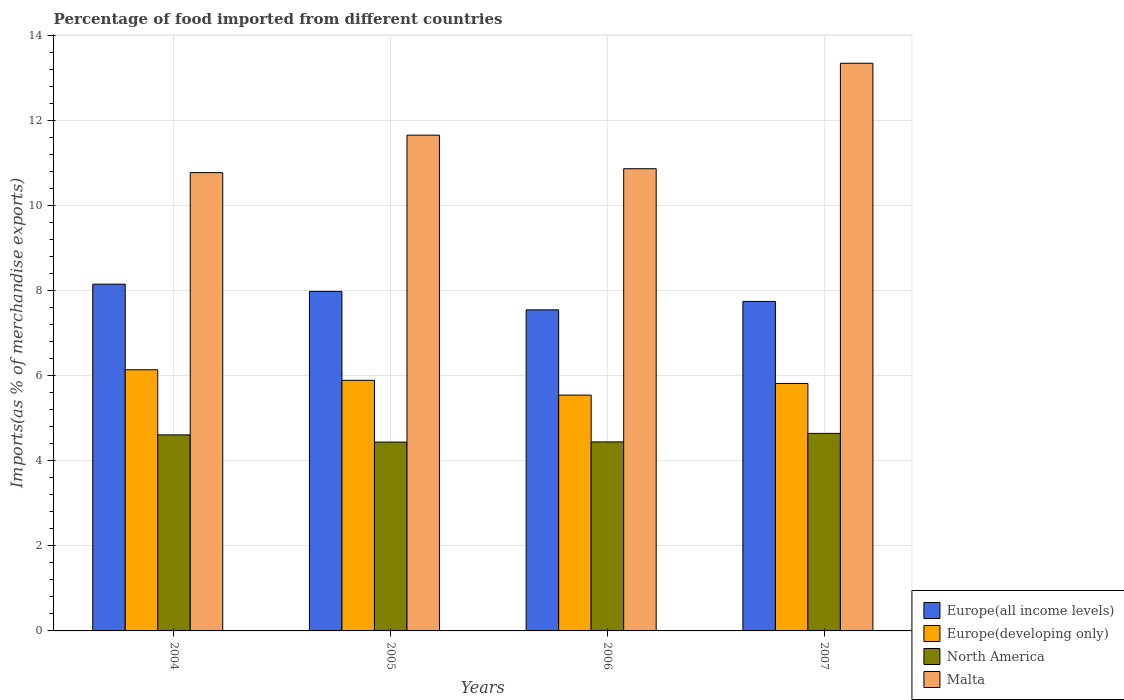How many different coloured bars are there?
Provide a succinct answer. 4. Are the number of bars per tick equal to the number of legend labels?
Offer a terse response. Yes. How many bars are there on the 4th tick from the left?
Give a very brief answer. 4. What is the label of the 3rd group of bars from the left?
Keep it short and to the point. 2006. In how many cases, is the number of bars for a given year not equal to the number of legend labels?
Offer a very short reply. 0. What is the percentage of imports to different countries in Europe(developing only) in 2006?
Make the answer very short. 5.54. Across all years, what is the maximum percentage of imports to different countries in Europe(developing only)?
Ensure brevity in your answer.  6.14. Across all years, what is the minimum percentage of imports to different countries in Europe(all income levels)?
Your answer should be very brief. 7.54. In which year was the percentage of imports to different countries in Europe(all income levels) minimum?
Your response must be concise. 2006. What is the total percentage of imports to different countries in North America in the graph?
Offer a very short reply. 18.13. What is the difference between the percentage of imports to different countries in Europe(all income levels) in 2004 and that in 2007?
Ensure brevity in your answer.  0.41. What is the difference between the percentage of imports to different countries in North America in 2005 and the percentage of imports to different countries in Europe(all income levels) in 2004?
Ensure brevity in your answer.  -3.71. What is the average percentage of imports to different countries in Europe(all income levels) per year?
Your answer should be very brief. 7.85. In the year 2005, what is the difference between the percentage of imports to different countries in Malta and percentage of imports to different countries in North America?
Your response must be concise. 7.21. In how many years, is the percentage of imports to different countries in Europe(all income levels) greater than 3.2 %?
Provide a short and direct response. 4. What is the ratio of the percentage of imports to different countries in Europe(all income levels) in 2004 to that in 2007?
Ensure brevity in your answer.  1.05. Is the difference between the percentage of imports to different countries in Malta in 2004 and 2007 greater than the difference between the percentage of imports to different countries in North America in 2004 and 2007?
Your response must be concise. No. What is the difference between the highest and the second highest percentage of imports to different countries in North America?
Offer a very short reply. 0.04. What is the difference between the highest and the lowest percentage of imports to different countries in Malta?
Provide a short and direct response. 2.57. What does the 3rd bar from the left in 2007 represents?
Give a very brief answer. North America. Are all the bars in the graph horizontal?
Provide a short and direct response. No. How many years are there in the graph?
Offer a very short reply. 4. What is the difference between two consecutive major ticks on the Y-axis?
Your answer should be very brief. 2. Are the values on the major ticks of Y-axis written in scientific E-notation?
Make the answer very short. No. Does the graph contain any zero values?
Offer a very short reply. No. Does the graph contain grids?
Provide a short and direct response. Yes. How many legend labels are there?
Your answer should be very brief. 4. How are the legend labels stacked?
Give a very brief answer. Vertical. What is the title of the graph?
Offer a terse response. Percentage of food imported from different countries. What is the label or title of the X-axis?
Give a very brief answer. Years. What is the label or title of the Y-axis?
Keep it short and to the point. Imports(as % of merchandise exports). What is the Imports(as % of merchandise exports) in Europe(all income levels) in 2004?
Offer a terse response. 8.15. What is the Imports(as % of merchandise exports) of Europe(developing only) in 2004?
Offer a very short reply. 6.14. What is the Imports(as % of merchandise exports) in North America in 2004?
Make the answer very short. 4.61. What is the Imports(as % of merchandise exports) of Malta in 2004?
Offer a very short reply. 10.77. What is the Imports(as % of merchandise exports) in Europe(all income levels) in 2005?
Your answer should be compact. 7.98. What is the Imports(as % of merchandise exports) of Europe(developing only) in 2005?
Give a very brief answer. 5.89. What is the Imports(as % of merchandise exports) in North America in 2005?
Your response must be concise. 4.44. What is the Imports(as % of merchandise exports) in Malta in 2005?
Ensure brevity in your answer.  11.65. What is the Imports(as % of merchandise exports) in Europe(all income levels) in 2006?
Your answer should be very brief. 7.54. What is the Imports(as % of merchandise exports) of Europe(developing only) in 2006?
Give a very brief answer. 5.54. What is the Imports(as % of merchandise exports) in North America in 2006?
Provide a succinct answer. 4.44. What is the Imports(as % of merchandise exports) in Malta in 2006?
Keep it short and to the point. 10.86. What is the Imports(as % of merchandise exports) of Europe(all income levels) in 2007?
Your response must be concise. 7.74. What is the Imports(as % of merchandise exports) of Europe(developing only) in 2007?
Provide a short and direct response. 5.82. What is the Imports(as % of merchandise exports) in North America in 2007?
Keep it short and to the point. 4.64. What is the Imports(as % of merchandise exports) of Malta in 2007?
Make the answer very short. 13.34. Across all years, what is the maximum Imports(as % of merchandise exports) in Europe(all income levels)?
Ensure brevity in your answer.  8.15. Across all years, what is the maximum Imports(as % of merchandise exports) in Europe(developing only)?
Give a very brief answer. 6.14. Across all years, what is the maximum Imports(as % of merchandise exports) in North America?
Offer a terse response. 4.64. Across all years, what is the maximum Imports(as % of merchandise exports) in Malta?
Your response must be concise. 13.34. Across all years, what is the minimum Imports(as % of merchandise exports) of Europe(all income levels)?
Offer a very short reply. 7.54. Across all years, what is the minimum Imports(as % of merchandise exports) of Europe(developing only)?
Provide a short and direct response. 5.54. Across all years, what is the minimum Imports(as % of merchandise exports) of North America?
Keep it short and to the point. 4.44. Across all years, what is the minimum Imports(as % of merchandise exports) of Malta?
Your answer should be very brief. 10.77. What is the total Imports(as % of merchandise exports) of Europe(all income levels) in the graph?
Your answer should be very brief. 31.41. What is the total Imports(as % of merchandise exports) of Europe(developing only) in the graph?
Your answer should be compact. 23.38. What is the total Imports(as % of merchandise exports) of North America in the graph?
Provide a short and direct response. 18.13. What is the total Imports(as % of merchandise exports) in Malta in the graph?
Provide a short and direct response. 46.62. What is the difference between the Imports(as % of merchandise exports) in Europe(all income levels) in 2004 and that in 2005?
Provide a short and direct response. 0.17. What is the difference between the Imports(as % of merchandise exports) in Europe(developing only) in 2004 and that in 2005?
Offer a very short reply. 0.25. What is the difference between the Imports(as % of merchandise exports) in North America in 2004 and that in 2005?
Ensure brevity in your answer.  0.17. What is the difference between the Imports(as % of merchandise exports) in Malta in 2004 and that in 2005?
Provide a succinct answer. -0.88. What is the difference between the Imports(as % of merchandise exports) in Europe(all income levels) in 2004 and that in 2006?
Give a very brief answer. 0.6. What is the difference between the Imports(as % of merchandise exports) of Europe(developing only) in 2004 and that in 2006?
Provide a short and direct response. 0.6. What is the difference between the Imports(as % of merchandise exports) of North America in 2004 and that in 2006?
Your answer should be very brief. 0.16. What is the difference between the Imports(as % of merchandise exports) in Malta in 2004 and that in 2006?
Offer a terse response. -0.09. What is the difference between the Imports(as % of merchandise exports) in Europe(all income levels) in 2004 and that in 2007?
Give a very brief answer. 0.41. What is the difference between the Imports(as % of merchandise exports) in Europe(developing only) in 2004 and that in 2007?
Offer a very short reply. 0.32. What is the difference between the Imports(as % of merchandise exports) in North America in 2004 and that in 2007?
Your answer should be compact. -0.04. What is the difference between the Imports(as % of merchandise exports) of Malta in 2004 and that in 2007?
Your response must be concise. -2.57. What is the difference between the Imports(as % of merchandise exports) in Europe(all income levels) in 2005 and that in 2006?
Your answer should be compact. 0.43. What is the difference between the Imports(as % of merchandise exports) of Europe(developing only) in 2005 and that in 2006?
Offer a very short reply. 0.35. What is the difference between the Imports(as % of merchandise exports) of North America in 2005 and that in 2006?
Make the answer very short. -0. What is the difference between the Imports(as % of merchandise exports) in Malta in 2005 and that in 2006?
Ensure brevity in your answer.  0.79. What is the difference between the Imports(as % of merchandise exports) in Europe(all income levels) in 2005 and that in 2007?
Give a very brief answer. 0.24. What is the difference between the Imports(as % of merchandise exports) in Europe(developing only) in 2005 and that in 2007?
Offer a terse response. 0.07. What is the difference between the Imports(as % of merchandise exports) in North America in 2005 and that in 2007?
Offer a terse response. -0.2. What is the difference between the Imports(as % of merchandise exports) in Malta in 2005 and that in 2007?
Offer a terse response. -1.69. What is the difference between the Imports(as % of merchandise exports) of Europe(all income levels) in 2006 and that in 2007?
Your answer should be very brief. -0.2. What is the difference between the Imports(as % of merchandise exports) of Europe(developing only) in 2006 and that in 2007?
Offer a terse response. -0.27. What is the difference between the Imports(as % of merchandise exports) of North America in 2006 and that in 2007?
Ensure brevity in your answer.  -0.2. What is the difference between the Imports(as % of merchandise exports) in Malta in 2006 and that in 2007?
Make the answer very short. -2.48. What is the difference between the Imports(as % of merchandise exports) of Europe(all income levels) in 2004 and the Imports(as % of merchandise exports) of Europe(developing only) in 2005?
Your response must be concise. 2.26. What is the difference between the Imports(as % of merchandise exports) in Europe(all income levels) in 2004 and the Imports(as % of merchandise exports) in North America in 2005?
Your answer should be very brief. 3.71. What is the difference between the Imports(as % of merchandise exports) in Europe(all income levels) in 2004 and the Imports(as % of merchandise exports) in Malta in 2005?
Ensure brevity in your answer.  -3.5. What is the difference between the Imports(as % of merchandise exports) in Europe(developing only) in 2004 and the Imports(as % of merchandise exports) in North America in 2005?
Offer a terse response. 1.7. What is the difference between the Imports(as % of merchandise exports) of Europe(developing only) in 2004 and the Imports(as % of merchandise exports) of Malta in 2005?
Make the answer very short. -5.51. What is the difference between the Imports(as % of merchandise exports) in North America in 2004 and the Imports(as % of merchandise exports) in Malta in 2005?
Provide a succinct answer. -7.04. What is the difference between the Imports(as % of merchandise exports) of Europe(all income levels) in 2004 and the Imports(as % of merchandise exports) of Europe(developing only) in 2006?
Your answer should be very brief. 2.61. What is the difference between the Imports(as % of merchandise exports) in Europe(all income levels) in 2004 and the Imports(as % of merchandise exports) in North America in 2006?
Your response must be concise. 3.71. What is the difference between the Imports(as % of merchandise exports) of Europe(all income levels) in 2004 and the Imports(as % of merchandise exports) of Malta in 2006?
Offer a very short reply. -2.71. What is the difference between the Imports(as % of merchandise exports) in Europe(developing only) in 2004 and the Imports(as % of merchandise exports) in North America in 2006?
Keep it short and to the point. 1.69. What is the difference between the Imports(as % of merchandise exports) in Europe(developing only) in 2004 and the Imports(as % of merchandise exports) in Malta in 2006?
Offer a terse response. -4.72. What is the difference between the Imports(as % of merchandise exports) of North America in 2004 and the Imports(as % of merchandise exports) of Malta in 2006?
Offer a very short reply. -6.25. What is the difference between the Imports(as % of merchandise exports) in Europe(all income levels) in 2004 and the Imports(as % of merchandise exports) in Europe(developing only) in 2007?
Offer a terse response. 2.33. What is the difference between the Imports(as % of merchandise exports) of Europe(all income levels) in 2004 and the Imports(as % of merchandise exports) of North America in 2007?
Offer a terse response. 3.51. What is the difference between the Imports(as % of merchandise exports) in Europe(all income levels) in 2004 and the Imports(as % of merchandise exports) in Malta in 2007?
Offer a very short reply. -5.19. What is the difference between the Imports(as % of merchandise exports) of Europe(developing only) in 2004 and the Imports(as % of merchandise exports) of North America in 2007?
Your answer should be compact. 1.49. What is the difference between the Imports(as % of merchandise exports) of Europe(developing only) in 2004 and the Imports(as % of merchandise exports) of Malta in 2007?
Your answer should be very brief. -7.2. What is the difference between the Imports(as % of merchandise exports) of North America in 2004 and the Imports(as % of merchandise exports) of Malta in 2007?
Keep it short and to the point. -8.73. What is the difference between the Imports(as % of merchandise exports) in Europe(all income levels) in 2005 and the Imports(as % of merchandise exports) in Europe(developing only) in 2006?
Offer a terse response. 2.44. What is the difference between the Imports(as % of merchandise exports) in Europe(all income levels) in 2005 and the Imports(as % of merchandise exports) in North America in 2006?
Your response must be concise. 3.54. What is the difference between the Imports(as % of merchandise exports) of Europe(all income levels) in 2005 and the Imports(as % of merchandise exports) of Malta in 2006?
Keep it short and to the point. -2.88. What is the difference between the Imports(as % of merchandise exports) in Europe(developing only) in 2005 and the Imports(as % of merchandise exports) in North America in 2006?
Make the answer very short. 1.45. What is the difference between the Imports(as % of merchandise exports) of Europe(developing only) in 2005 and the Imports(as % of merchandise exports) of Malta in 2006?
Your answer should be very brief. -4.97. What is the difference between the Imports(as % of merchandise exports) in North America in 2005 and the Imports(as % of merchandise exports) in Malta in 2006?
Offer a terse response. -6.42. What is the difference between the Imports(as % of merchandise exports) of Europe(all income levels) in 2005 and the Imports(as % of merchandise exports) of Europe(developing only) in 2007?
Provide a succinct answer. 2.16. What is the difference between the Imports(as % of merchandise exports) of Europe(all income levels) in 2005 and the Imports(as % of merchandise exports) of North America in 2007?
Offer a very short reply. 3.34. What is the difference between the Imports(as % of merchandise exports) of Europe(all income levels) in 2005 and the Imports(as % of merchandise exports) of Malta in 2007?
Provide a succinct answer. -5.36. What is the difference between the Imports(as % of merchandise exports) in Europe(developing only) in 2005 and the Imports(as % of merchandise exports) in North America in 2007?
Give a very brief answer. 1.25. What is the difference between the Imports(as % of merchandise exports) of Europe(developing only) in 2005 and the Imports(as % of merchandise exports) of Malta in 2007?
Keep it short and to the point. -7.45. What is the difference between the Imports(as % of merchandise exports) of North America in 2005 and the Imports(as % of merchandise exports) of Malta in 2007?
Give a very brief answer. -8.9. What is the difference between the Imports(as % of merchandise exports) of Europe(all income levels) in 2006 and the Imports(as % of merchandise exports) of Europe(developing only) in 2007?
Your response must be concise. 1.73. What is the difference between the Imports(as % of merchandise exports) of Europe(all income levels) in 2006 and the Imports(as % of merchandise exports) of North America in 2007?
Your answer should be compact. 2.9. What is the difference between the Imports(as % of merchandise exports) of Europe(all income levels) in 2006 and the Imports(as % of merchandise exports) of Malta in 2007?
Offer a terse response. -5.79. What is the difference between the Imports(as % of merchandise exports) in Europe(developing only) in 2006 and the Imports(as % of merchandise exports) in North America in 2007?
Your answer should be compact. 0.9. What is the difference between the Imports(as % of merchandise exports) in Europe(developing only) in 2006 and the Imports(as % of merchandise exports) in Malta in 2007?
Offer a terse response. -7.8. What is the difference between the Imports(as % of merchandise exports) of North America in 2006 and the Imports(as % of merchandise exports) of Malta in 2007?
Offer a very short reply. -8.9. What is the average Imports(as % of merchandise exports) of Europe(all income levels) per year?
Provide a succinct answer. 7.85. What is the average Imports(as % of merchandise exports) in Europe(developing only) per year?
Your answer should be very brief. 5.85. What is the average Imports(as % of merchandise exports) of North America per year?
Keep it short and to the point. 4.53. What is the average Imports(as % of merchandise exports) of Malta per year?
Offer a terse response. 11.65. In the year 2004, what is the difference between the Imports(as % of merchandise exports) of Europe(all income levels) and Imports(as % of merchandise exports) of Europe(developing only)?
Make the answer very short. 2.01. In the year 2004, what is the difference between the Imports(as % of merchandise exports) of Europe(all income levels) and Imports(as % of merchandise exports) of North America?
Offer a very short reply. 3.54. In the year 2004, what is the difference between the Imports(as % of merchandise exports) in Europe(all income levels) and Imports(as % of merchandise exports) in Malta?
Provide a short and direct response. -2.62. In the year 2004, what is the difference between the Imports(as % of merchandise exports) of Europe(developing only) and Imports(as % of merchandise exports) of North America?
Your response must be concise. 1.53. In the year 2004, what is the difference between the Imports(as % of merchandise exports) in Europe(developing only) and Imports(as % of merchandise exports) in Malta?
Provide a succinct answer. -4.63. In the year 2004, what is the difference between the Imports(as % of merchandise exports) of North America and Imports(as % of merchandise exports) of Malta?
Provide a succinct answer. -6.16. In the year 2005, what is the difference between the Imports(as % of merchandise exports) of Europe(all income levels) and Imports(as % of merchandise exports) of Europe(developing only)?
Your response must be concise. 2.09. In the year 2005, what is the difference between the Imports(as % of merchandise exports) in Europe(all income levels) and Imports(as % of merchandise exports) in North America?
Provide a succinct answer. 3.54. In the year 2005, what is the difference between the Imports(as % of merchandise exports) in Europe(all income levels) and Imports(as % of merchandise exports) in Malta?
Keep it short and to the point. -3.67. In the year 2005, what is the difference between the Imports(as % of merchandise exports) in Europe(developing only) and Imports(as % of merchandise exports) in North America?
Give a very brief answer. 1.45. In the year 2005, what is the difference between the Imports(as % of merchandise exports) in Europe(developing only) and Imports(as % of merchandise exports) in Malta?
Give a very brief answer. -5.76. In the year 2005, what is the difference between the Imports(as % of merchandise exports) in North America and Imports(as % of merchandise exports) in Malta?
Keep it short and to the point. -7.21. In the year 2006, what is the difference between the Imports(as % of merchandise exports) in Europe(all income levels) and Imports(as % of merchandise exports) in Europe(developing only)?
Offer a very short reply. 2. In the year 2006, what is the difference between the Imports(as % of merchandise exports) of Europe(all income levels) and Imports(as % of merchandise exports) of North America?
Provide a succinct answer. 3.1. In the year 2006, what is the difference between the Imports(as % of merchandise exports) in Europe(all income levels) and Imports(as % of merchandise exports) in Malta?
Keep it short and to the point. -3.32. In the year 2006, what is the difference between the Imports(as % of merchandise exports) in Europe(developing only) and Imports(as % of merchandise exports) in North America?
Offer a terse response. 1.1. In the year 2006, what is the difference between the Imports(as % of merchandise exports) in Europe(developing only) and Imports(as % of merchandise exports) in Malta?
Your answer should be compact. -5.32. In the year 2006, what is the difference between the Imports(as % of merchandise exports) in North America and Imports(as % of merchandise exports) in Malta?
Your response must be concise. -6.42. In the year 2007, what is the difference between the Imports(as % of merchandise exports) in Europe(all income levels) and Imports(as % of merchandise exports) in Europe(developing only)?
Give a very brief answer. 1.93. In the year 2007, what is the difference between the Imports(as % of merchandise exports) in Europe(all income levels) and Imports(as % of merchandise exports) in North America?
Offer a very short reply. 3.1. In the year 2007, what is the difference between the Imports(as % of merchandise exports) of Europe(all income levels) and Imports(as % of merchandise exports) of Malta?
Give a very brief answer. -5.6. In the year 2007, what is the difference between the Imports(as % of merchandise exports) of Europe(developing only) and Imports(as % of merchandise exports) of North America?
Keep it short and to the point. 1.17. In the year 2007, what is the difference between the Imports(as % of merchandise exports) in Europe(developing only) and Imports(as % of merchandise exports) in Malta?
Provide a succinct answer. -7.52. In the year 2007, what is the difference between the Imports(as % of merchandise exports) in North America and Imports(as % of merchandise exports) in Malta?
Ensure brevity in your answer.  -8.7. What is the ratio of the Imports(as % of merchandise exports) of Europe(all income levels) in 2004 to that in 2005?
Give a very brief answer. 1.02. What is the ratio of the Imports(as % of merchandise exports) in Europe(developing only) in 2004 to that in 2005?
Provide a short and direct response. 1.04. What is the ratio of the Imports(as % of merchandise exports) of North America in 2004 to that in 2005?
Your answer should be very brief. 1.04. What is the ratio of the Imports(as % of merchandise exports) of Malta in 2004 to that in 2005?
Your response must be concise. 0.92. What is the ratio of the Imports(as % of merchandise exports) of Europe(all income levels) in 2004 to that in 2006?
Provide a short and direct response. 1.08. What is the ratio of the Imports(as % of merchandise exports) of Europe(developing only) in 2004 to that in 2006?
Your response must be concise. 1.11. What is the ratio of the Imports(as % of merchandise exports) of North America in 2004 to that in 2006?
Provide a short and direct response. 1.04. What is the ratio of the Imports(as % of merchandise exports) of Europe(all income levels) in 2004 to that in 2007?
Offer a very short reply. 1.05. What is the ratio of the Imports(as % of merchandise exports) in Europe(developing only) in 2004 to that in 2007?
Your answer should be compact. 1.06. What is the ratio of the Imports(as % of merchandise exports) of Malta in 2004 to that in 2007?
Give a very brief answer. 0.81. What is the ratio of the Imports(as % of merchandise exports) of Europe(all income levels) in 2005 to that in 2006?
Make the answer very short. 1.06. What is the ratio of the Imports(as % of merchandise exports) of Europe(developing only) in 2005 to that in 2006?
Offer a very short reply. 1.06. What is the ratio of the Imports(as % of merchandise exports) of North America in 2005 to that in 2006?
Ensure brevity in your answer.  1. What is the ratio of the Imports(as % of merchandise exports) in Malta in 2005 to that in 2006?
Ensure brevity in your answer.  1.07. What is the ratio of the Imports(as % of merchandise exports) of Europe(all income levels) in 2005 to that in 2007?
Your response must be concise. 1.03. What is the ratio of the Imports(as % of merchandise exports) of Europe(developing only) in 2005 to that in 2007?
Your answer should be compact. 1.01. What is the ratio of the Imports(as % of merchandise exports) in North America in 2005 to that in 2007?
Your answer should be compact. 0.96. What is the ratio of the Imports(as % of merchandise exports) in Malta in 2005 to that in 2007?
Your response must be concise. 0.87. What is the ratio of the Imports(as % of merchandise exports) of Europe(all income levels) in 2006 to that in 2007?
Make the answer very short. 0.97. What is the ratio of the Imports(as % of merchandise exports) in Europe(developing only) in 2006 to that in 2007?
Keep it short and to the point. 0.95. What is the ratio of the Imports(as % of merchandise exports) of North America in 2006 to that in 2007?
Your answer should be very brief. 0.96. What is the ratio of the Imports(as % of merchandise exports) in Malta in 2006 to that in 2007?
Provide a short and direct response. 0.81. What is the difference between the highest and the second highest Imports(as % of merchandise exports) in Europe(all income levels)?
Make the answer very short. 0.17. What is the difference between the highest and the second highest Imports(as % of merchandise exports) of Europe(developing only)?
Give a very brief answer. 0.25. What is the difference between the highest and the second highest Imports(as % of merchandise exports) of North America?
Your answer should be compact. 0.04. What is the difference between the highest and the second highest Imports(as % of merchandise exports) of Malta?
Your answer should be compact. 1.69. What is the difference between the highest and the lowest Imports(as % of merchandise exports) in Europe(all income levels)?
Provide a short and direct response. 0.6. What is the difference between the highest and the lowest Imports(as % of merchandise exports) of Europe(developing only)?
Provide a succinct answer. 0.6. What is the difference between the highest and the lowest Imports(as % of merchandise exports) in North America?
Provide a succinct answer. 0.2. What is the difference between the highest and the lowest Imports(as % of merchandise exports) in Malta?
Keep it short and to the point. 2.57. 